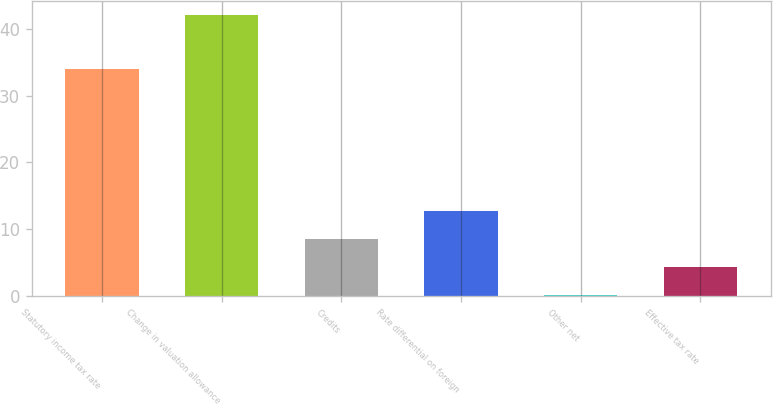<chart> <loc_0><loc_0><loc_500><loc_500><bar_chart><fcel>Statutory income tax rate<fcel>Change in valuation allowance<fcel>Credits<fcel>Rate differential on foreign<fcel>Other net<fcel>Effective tax rate<nl><fcel>34<fcel>42<fcel>8.56<fcel>12.74<fcel>0.2<fcel>4.38<nl></chart> 